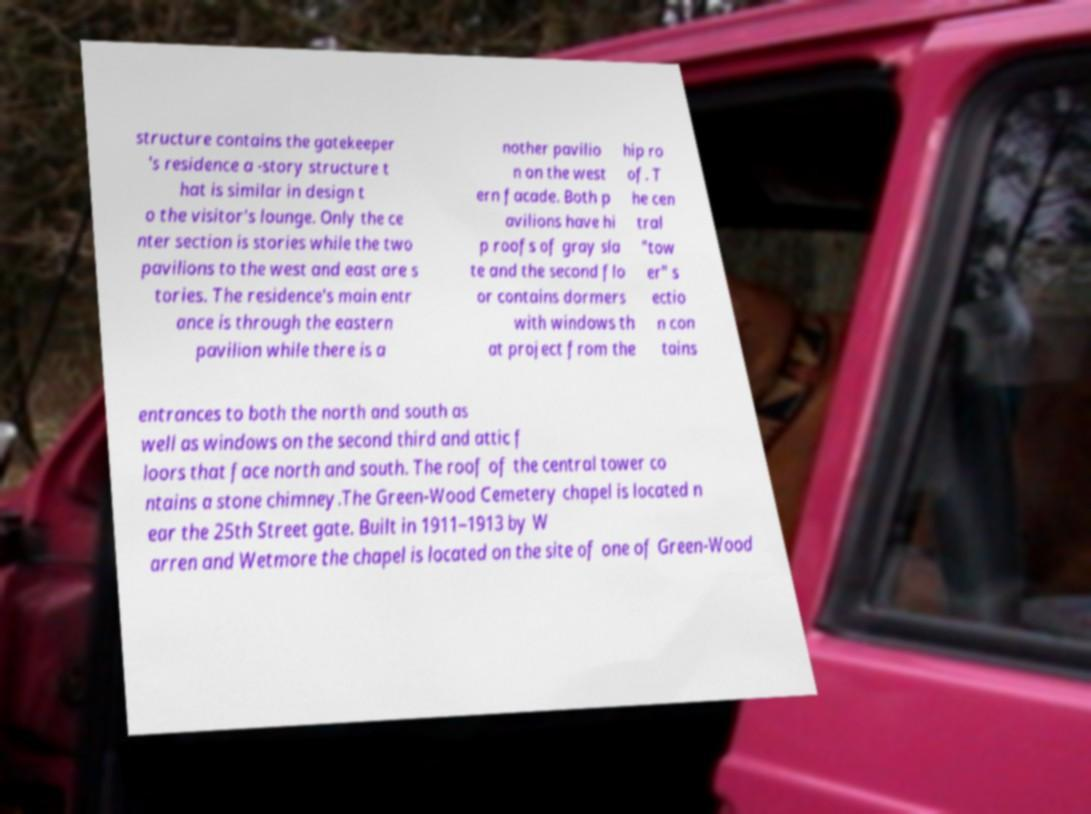What messages or text are displayed in this image? I need them in a readable, typed format. structure contains the gatekeeper 's residence a -story structure t hat is similar in design t o the visitor's lounge. Only the ce nter section is stories while the two pavilions to the west and east are s tories. The residence's main entr ance is through the eastern pavilion while there is a nother pavilio n on the west ern facade. Both p avilions have hi p roofs of gray sla te and the second flo or contains dormers with windows th at project from the hip ro of. T he cen tral "tow er" s ectio n con tains entrances to both the north and south as well as windows on the second third and attic f loors that face north and south. The roof of the central tower co ntains a stone chimney.The Green-Wood Cemetery chapel is located n ear the 25th Street gate. Built in 1911–1913 by W arren and Wetmore the chapel is located on the site of one of Green-Wood 